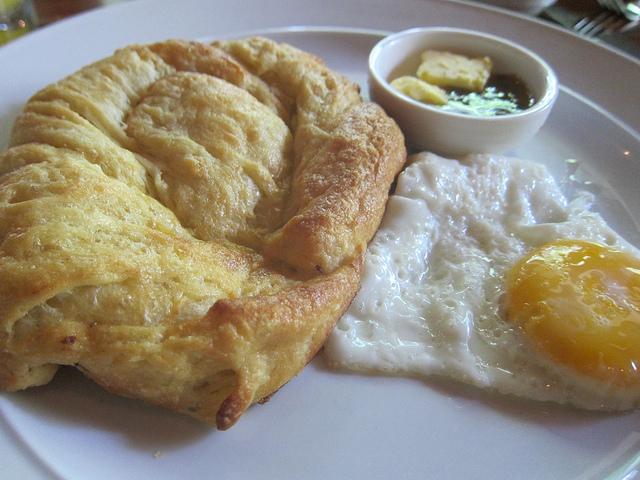What shape is the plate?
Give a very brief answer. Round. Is the dish red?
Write a very short answer. No. Is that a poached egg?
Concise answer only. No. Is this breakfast?
Write a very short answer. Yes. 